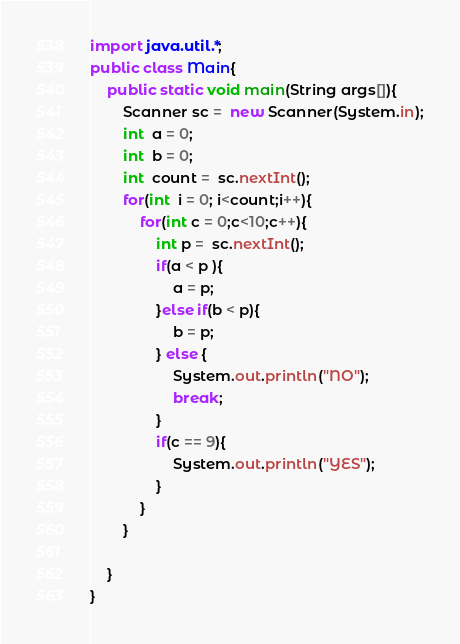Convert code to text. <code><loc_0><loc_0><loc_500><loc_500><_Java_>import java.util.*;
public class Main{
	public static void main(String args[]){
		Scanner sc =  new Scanner(System.in);
		int  a = 0;
		int  b = 0;
		int  count =  sc.nextInt();
		for(int  i = 0; i<count;i++){
			for(int c = 0;c<10;c++){
				int p =  sc.nextInt();
				if(a < p ){
					a = p;
				}else if(b < p){
					b = p;
				} else {
					System.out.println("NO");
					break;
				}
				if(c == 9){
					System.out.println("YES");
				}
			}
		}
		
	}
}</code> 